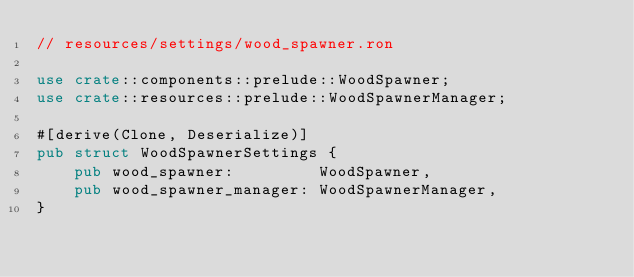<code> <loc_0><loc_0><loc_500><loc_500><_Rust_>// resources/settings/wood_spawner.ron

use crate::components::prelude::WoodSpawner;
use crate::resources::prelude::WoodSpawnerManager;

#[derive(Clone, Deserialize)]
pub struct WoodSpawnerSettings {
    pub wood_spawner:         WoodSpawner,
    pub wood_spawner_manager: WoodSpawnerManager,
}
</code> 